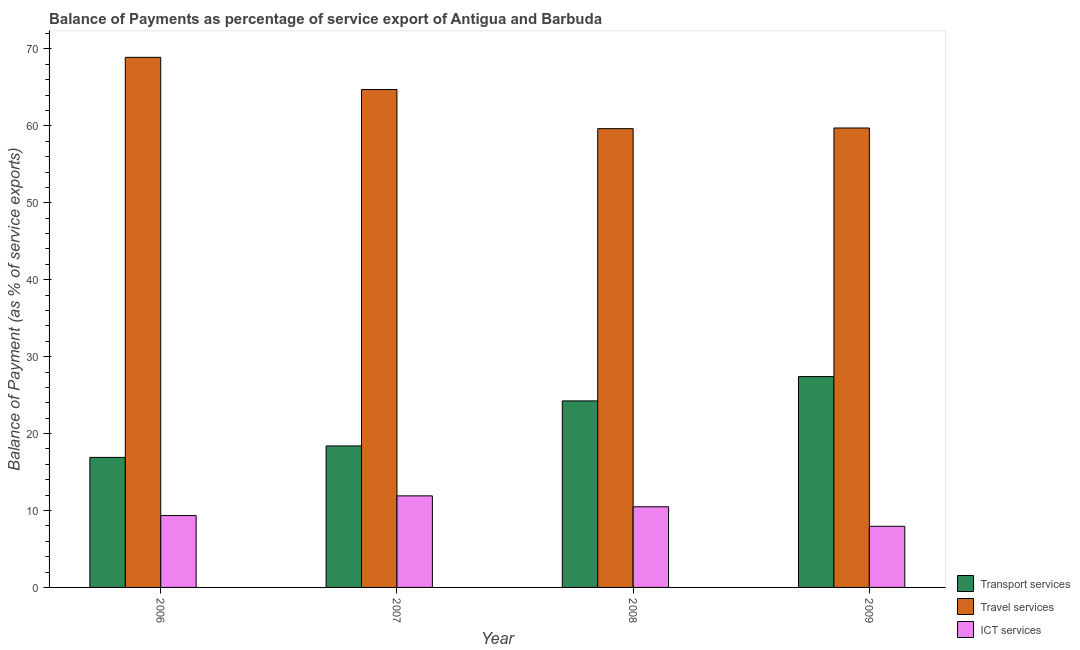How many bars are there on the 3rd tick from the right?
Offer a terse response. 3. What is the label of the 4th group of bars from the left?
Ensure brevity in your answer.  2009. What is the balance of payment of transport services in 2007?
Offer a terse response. 18.39. Across all years, what is the maximum balance of payment of transport services?
Provide a succinct answer. 27.41. Across all years, what is the minimum balance of payment of travel services?
Keep it short and to the point. 59.64. In which year was the balance of payment of transport services minimum?
Provide a short and direct response. 2006. What is the total balance of payment of transport services in the graph?
Provide a succinct answer. 86.95. What is the difference between the balance of payment of ict services in 2008 and that in 2009?
Your answer should be very brief. 2.54. What is the difference between the balance of payment of travel services in 2007 and the balance of payment of transport services in 2006?
Offer a very short reply. -4.18. What is the average balance of payment of transport services per year?
Offer a very short reply. 21.74. In the year 2007, what is the difference between the balance of payment of transport services and balance of payment of ict services?
Keep it short and to the point. 0. In how many years, is the balance of payment of travel services greater than 42 %?
Give a very brief answer. 4. What is the ratio of the balance of payment of transport services in 2006 to that in 2008?
Ensure brevity in your answer.  0.7. Is the balance of payment of transport services in 2006 less than that in 2008?
Give a very brief answer. Yes. Is the difference between the balance of payment of ict services in 2006 and 2009 greater than the difference between the balance of payment of transport services in 2006 and 2009?
Provide a short and direct response. No. What is the difference between the highest and the second highest balance of payment of transport services?
Your answer should be very brief. 3.16. What is the difference between the highest and the lowest balance of payment of transport services?
Offer a very short reply. 10.51. In how many years, is the balance of payment of ict services greater than the average balance of payment of ict services taken over all years?
Ensure brevity in your answer.  2. What does the 1st bar from the left in 2009 represents?
Provide a succinct answer. Transport services. What does the 3rd bar from the right in 2006 represents?
Ensure brevity in your answer.  Transport services. Is it the case that in every year, the sum of the balance of payment of transport services and balance of payment of travel services is greater than the balance of payment of ict services?
Make the answer very short. Yes. Are all the bars in the graph horizontal?
Make the answer very short. No. Are the values on the major ticks of Y-axis written in scientific E-notation?
Offer a very short reply. No. Does the graph contain any zero values?
Provide a succinct answer. No. Where does the legend appear in the graph?
Keep it short and to the point. Bottom right. How many legend labels are there?
Your answer should be compact. 3. How are the legend labels stacked?
Your answer should be compact. Vertical. What is the title of the graph?
Your answer should be very brief. Balance of Payments as percentage of service export of Antigua and Barbuda. Does "Gaseous fuel" appear as one of the legend labels in the graph?
Your response must be concise. No. What is the label or title of the X-axis?
Keep it short and to the point. Year. What is the label or title of the Y-axis?
Ensure brevity in your answer.  Balance of Payment (as % of service exports). What is the Balance of Payment (as % of service exports) of Transport services in 2006?
Give a very brief answer. 16.9. What is the Balance of Payment (as % of service exports) in Travel services in 2006?
Your answer should be compact. 68.91. What is the Balance of Payment (as % of service exports) of ICT services in 2006?
Provide a succinct answer. 9.34. What is the Balance of Payment (as % of service exports) of Transport services in 2007?
Give a very brief answer. 18.39. What is the Balance of Payment (as % of service exports) of Travel services in 2007?
Keep it short and to the point. 64.73. What is the Balance of Payment (as % of service exports) of ICT services in 2007?
Provide a short and direct response. 11.9. What is the Balance of Payment (as % of service exports) of Transport services in 2008?
Provide a succinct answer. 24.25. What is the Balance of Payment (as % of service exports) of Travel services in 2008?
Provide a short and direct response. 59.64. What is the Balance of Payment (as % of service exports) in ICT services in 2008?
Provide a short and direct response. 10.48. What is the Balance of Payment (as % of service exports) of Transport services in 2009?
Keep it short and to the point. 27.41. What is the Balance of Payment (as % of service exports) in Travel services in 2009?
Provide a succinct answer. 59.72. What is the Balance of Payment (as % of service exports) in ICT services in 2009?
Provide a succinct answer. 7.95. Across all years, what is the maximum Balance of Payment (as % of service exports) of Transport services?
Your response must be concise. 27.41. Across all years, what is the maximum Balance of Payment (as % of service exports) of Travel services?
Make the answer very short. 68.91. Across all years, what is the maximum Balance of Payment (as % of service exports) of ICT services?
Ensure brevity in your answer.  11.9. Across all years, what is the minimum Balance of Payment (as % of service exports) of Transport services?
Provide a short and direct response. 16.9. Across all years, what is the minimum Balance of Payment (as % of service exports) of Travel services?
Your response must be concise. 59.64. Across all years, what is the minimum Balance of Payment (as % of service exports) of ICT services?
Ensure brevity in your answer.  7.95. What is the total Balance of Payment (as % of service exports) of Transport services in the graph?
Make the answer very short. 86.95. What is the total Balance of Payment (as % of service exports) of Travel services in the graph?
Make the answer very short. 253. What is the total Balance of Payment (as % of service exports) in ICT services in the graph?
Provide a short and direct response. 39.68. What is the difference between the Balance of Payment (as % of service exports) of Transport services in 2006 and that in 2007?
Keep it short and to the point. -1.49. What is the difference between the Balance of Payment (as % of service exports) of Travel services in 2006 and that in 2007?
Make the answer very short. 4.18. What is the difference between the Balance of Payment (as % of service exports) of ICT services in 2006 and that in 2007?
Your answer should be compact. -2.56. What is the difference between the Balance of Payment (as % of service exports) in Transport services in 2006 and that in 2008?
Provide a short and direct response. -7.35. What is the difference between the Balance of Payment (as % of service exports) of Travel services in 2006 and that in 2008?
Your answer should be compact. 9.27. What is the difference between the Balance of Payment (as % of service exports) of ICT services in 2006 and that in 2008?
Offer a terse response. -1.14. What is the difference between the Balance of Payment (as % of service exports) of Transport services in 2006 and that in 2009?
Give a very brief answer. -10.51. What is the difference between the Balance of Payment (as % of service exports) of Travel services in 2006 and that in 2009?
Your response must be concise. 9.19. What is the difference between the Balance of Payment (as % of service exports) in ICT services in 2006 and that in 2009?
Give a very brief answer. 1.39. What is the difference between the Balance of Payment (as % of service exports) in Transport services in 2007 and that in 2008?
Give a very brief answer. -5.85. What is the difference between the Balance of Payment (as % of service exports) of Travel services in 2007 and that in 2008?
Your response must be concise. 5.09. What is the difference between the Balance of Payment (as % of service exports) of ICT services in 2007 and that in 2008?
Give a very brief answer. 1.42. What is the difference between the Balance of Payment (as % of service exports) in Transport services in 2007 and that in 2009?
Provide a short and direct response. -9.01. What is the difference between the Balance of Payment (as % of service exports) of Travel services in 2007 and that in 2009?
Your answer should be very brief. 5. What is the difference between the Balance of Payment (as % of service exports) in ICT services in 2007 and that in 2009?
Offer a terse response. 3.96. What is the difference between the Balance of Payment (as % of service exports) in Transport services in 2008 and that in 2009?
Your answer should be very brief. -3.16. What is the difference between the Balance of Payment (as % of service exports) of Travel services in 2008 and that in 2009?
Your answer should be very brief. -0.08. What is the difference between the Balance of Payment (as % of service exports) of ICT services in 2008 and that in 2009?
Provide a succinct answer. 2.54. What is the difference between the Balance of Payment (as % of service exports) in Transport services in 2006 and the Balance of Payment (as % of service exports) in Travel services in 2007?
Provide a succinct answer. -47.83. What is the difference between the Balance of Payment (as % of service exports) in Transport services in 2006 and the Balance of Payment (as % of service exports) in ICT services in 2007?
Ensure brevity in your answer.  5. What is the difference between the Balance of Payment (as % of service exports) in Travel services in 2006 and the Balance of Payment (as % of service exports) in ICT services in 2007?
Provide a succinct answer. 57.01. What is the difference between the Balance of Payment (as % of service exports) in Transport services in 2006 and the Balance of Payment (as % of service exports) in Travel services in 2008?
Make the answer very short. -42.74. What is the difference between the Balance of Payment (as % of service exports) of Transport services in 2006 and the Balance of Payment (as % of service exports) of ICT services in 2008?
Your answer should be compact. 6.42. What is the difference between the Balance of Payment (as % of service exports) of Travel services in 2006 and the Balance of Payment (as % of service exports) of ICT services in 2008?
Provide a succinct answer. 58.42. What is the difference between the Balance of Payment (as % of service exports) of Transport services in 2006 and the Balance of Payment (as % of service exports) of Travel services in 2009?
Offer a very short reply. -42.82. What is the difference between the Balance of Payment (as % of service exports) in Transport services in 2006 and the Balance of Payment (as % of service exports) in ICT services in 2009?
Offer a very short reply. 8.96. What is the difference between the Balance of Payment (as % of service exports) in Travel services in 2006 and the Balance of Payment (as % of service exports) in ICT services in 2009?
Give a very brief answer. 60.96. What is the difference between the Balance of Payment (as % of service exports) in Transport services in 2007 and the Balance of Payment (as % of service exports) in Travel services in 2008?
Make the answer very short. -41.24. What is the difference between the Balance of Payment (as % of service exports) in Transport services in 2007 and the Balance of Payment (as % of service exports) in ICT services in 2008?
Offer a terse response. 7.91. What is the difference between the Balance of Payment (as % of service exports) in Travel services in 2007 and the Balance of Payment (as % of service exports) in ICT services in 2008?
Your response must be concise. 54.24. What is the difference between the Balance of Payment (as % of service exports) of Transport services in 2007 and the Balance of Payment (as % of service exports) of Travel services in 2009?
Offer a terse response. -41.33. What is the difference between the Balance of Payment (as % of service exports) in Transport services in 2007 and the Balance of Payment (as % of service exports) in ICT services in 2009?
Give a very brief answer. 10.45. What is the difference between the Balance of Payment (as % of service exports) of Travel services in 2007 and the Balance of Payment (as % of service exports) of ICT services in 2009?
Offer a very short reply. 56.78. What is the difference between the Balance of Payment (as % of service exports) in Transport services in 2008 and the Balance of Payment (as % of service exports) in Travel services in 2009?
Ensure brevity in your answer.  -35.48. What is the difference between the Balance of Payment (as % of service exports) in Transport services in 2008 and the Balance of Payment (as % of service exports) in ICT services in 2009?
Offer a terse response. 16.3. What is the difference between the Balance of Payment (as % of service exports) of Travel services in 2008 and the Balance of Payment (as % of service exports) of ICT services in 2009?
Your answer should be very brief. 51.69. What is the average Balance of Payment (as % of service exports) in Transport services per year?
Make the answer very short. 21.74. What is the average Balance of Payment (as % of service exports) of Travel services per year?
Your answer should be compact. 63.25. What is the average Balance of Payment (as % of service exports) of ICT services per year?
Make the answer very short. 9.92. In the year 2006, what is the difference between the Balance of Payment (as % of service exports) in Transport services and Balance of Payment (as % of service exports) in Travel services?
Offer a terse response. -52.01. In the year 2006, what is the difference between the Balance of Payment (as % of service exports) in Transport services and Balance of Payment (as % of service exports) in ICT services?
Ensure brevity in your answer.  7.56. In the year 2006, what is the difference between the Balance of Payment (as % of service exports) of Travel services and Balance of Payment (as % of service exports) of ICT services?
Make the answer very short. 59.57. In the year 2007, what is the difference between the Balance of Payment (as % of service exports) in Transport services and Balance of Payment (as % of service exports) in Travel services?
Provide a succinct answer. -46.33. In the year 2007, what is the difference between the Balance of Payment (as % of service exports) of Transport services and Balance of Payment (as % of service exports) of ICT services?
Offer a very short reply. 6.49. In the year 2007, what is the difference between the Balance of Payment (as % of service exports) of Travel services and Balance of Payment (as % of service exports) of ICT services?
Your answer should be compact. 52.82. In the year 2008, what is the difference between the Balance of Payment (as % of service exports) of Transport services and Balance of Payment (as % of service exports) of Travel services?
Provide a short and direct response. -35.39. In the year 2008, what is the difference between the Balance of Payment (as % of service exports) in Transport services and Balance of Payment (as % of service exports) in ICT services?
Offer a terse response. 13.76. In the year 2008, what is the difference between the Balance of Payment (as % of service exports) of Travel services and Balance of Payment (as % of service exports) of ICT services?
Your answer should be compact. 49.15. In the year 2009, what is the difference between the Balance of Payment (as % of service exports) in Transport services and Balance of Payment (as % of service exports) in Travel services?
Ensure brevity in your answer.  -32.32. In the year 2009, what is the difference between the Balance of Payment (as % of service exports) in Transport services and Balance of Payment (as % of service exports) in ICT services?
Your answer should be very brief. 19.46. In the year 2009, what is the difference between the Balance of Payment (as % of service exports) in Travel services and Balance of Payment (as % of service exports) in ICT services?
Your answer should be compact. 51.78. What is the ratio of the Balance of Payment (as % of service exports) in Transport services in 2006 to that in 2007?
Give a very brief answer. 0.92. What is the ratio of the Balance of Payment (as % of service exports) in Travel services in 2006 to that in 2007?
Offer a very short reply. 1.06. What is the ratio of the Balance of Payment (as % of service exports) of ICT services in 2006 to that in 2007?
Offer a terse response. 0.78. What is the ratio of the Balance of Payment (as % of service exports) of Transport services in 2006 to that in 2008?
Your answer should be compact. 0.7. What is the ratio of the Balance of Payment (as % of service exports) of Travel services in 2006 to that in 2008?
Keep it short and to the point. 1.16. What is the ratio of the Balance of Payment (as % of service exports) in ICT services in 2006 to that in 2008?
Give a very brief answer. 0.89. What is the ratio of the Balance of Payment (as % of service exports) of Transport services in 2006 to that in 2009?
Provide a succinct answer. 0.62. What is the ratio of the Balance of Payment (as % of service exports) of Travel services in 2006 to that in 2009?
Make the answer very short. 1.15. What is the ratio of the Balance of Payment (as % of service exports) in ICT services in 2006 to that in 2009?
Offer a terse response. 1.18. What is the ratio of the Balance of Payment (as % of service exports) of Transport services in 2007 to that in 2008?
Make the answer very short. 0.76. What is the ratio of the Balance of Payment (as % of service exports) in Travel services in 2007 to that in 2008?
Provide a succinct answer. 1.09. What is the ratio of the Balance of Payment (as % of service exports) in ICT services in 2007 to that in 2008?
Give a very brief answer. 1.14. What is the ratio of the Balance of Payment (as % of service exports) in Transport services in 2007 to that in 2009?
Offer a terse response. 0.67. What is the ratio of the Balance of Payment (as % of service exports) of Travel services in 2007 to that in 2009?
Your answer should be compact. 1.08. What is the ratio of the Balance of Payment (as % of service exports) in ICT services in 2007 to that in 2009?
Ensure brevity in your answer.  1.5. What is the ratio of the Balance of Payment (as % of service exports) in Transport services in 2008 to that in 2009?
Your answer should be compact. 0.88. What is the ratio of the Balance of Payment (as % of service exports) in ICT services in 2008 to that in 2009?
Offer a very short reply. 1.32. What is the difference between the highest and the second highest Balance of Payment (as % of service exports) in Transport services?
Your answer should be very brief. 3.16. What is the difference between the highest and the second highest Balance of Payment (as % of service exports) in Travel services?
Ensure brevity in your answer.  4.18. What is the difference between the highest and the second highest Balance of Payment (as % of service exports) of ICT services?
Ensure brevity in your answer.  1.42. What is the difference between the highest and the lowest Balance of Payment (as % of service exports) of Transport services?
Provide a succinct answer. 10.51. What is the difference between the highest and the lowest Balance of Payment (as % of service exports) in Travel services?
Ensure brevity in your answer.  9.27. What is the difference between the highest and the lowest Balance of Payment (as % of service exports) in ICT services?
Make the answer very short. 3.96. 